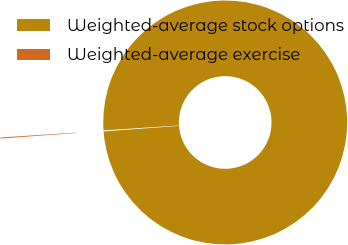Convert chart to OTSL. <chart><loc_0><loc_0><loc_500><loc_500><pie_chart><fcel>Weighted-average stock options<fcel>Weighted-average exercise<nl><fcel>99.86%<fcel>0.14%<nl></chart> 